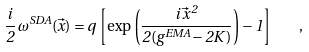Convert formula to latex. <formula><loc_0><loc_0><loc_500><loc_500>\frac { i } { 2 } \, \omega ^ { S D A } ( \vec { x } ) = q \, \left [ \exp \left ( \frac { i \, \vec { x } ^ { \, 2 } } { 2 ( g ^ { E M A } - 2 K ) } \right ) - 1 \right ] \quad ,</formula> 